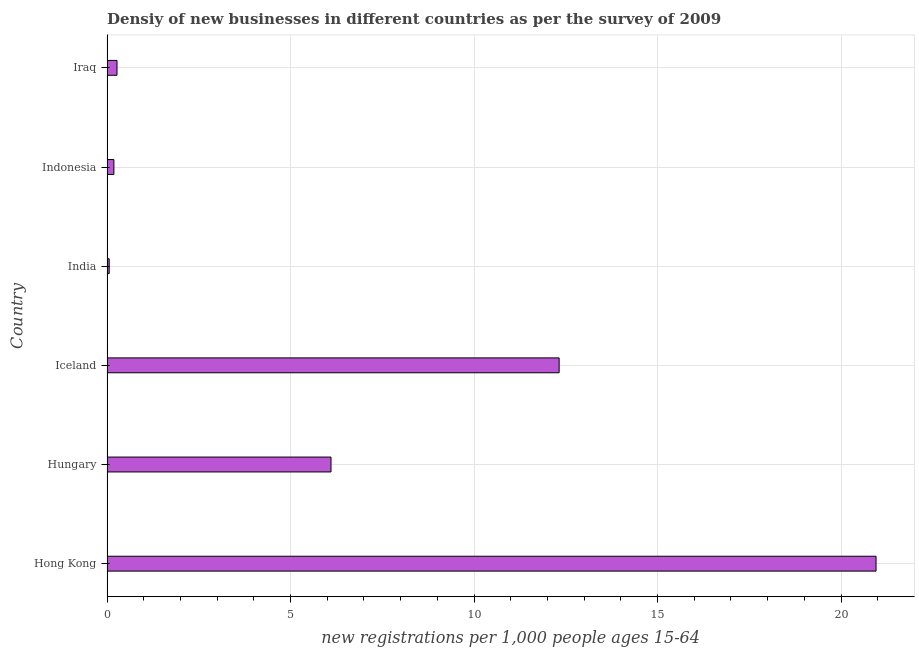Does the graph contain grids?
Your answer should be very brief. Yes. What is the title of the graph?
Keep it short and to the point. Densiy of new businesses in different countries as per the survey of 2009. What is the label or title of the X-axis?
Offer a very short reply. New registrations per 1,0 people ages 15-64. What is the label or title of the Y-axis?
Offer a terse response. Country. What is the density of new business in Hong Kong?
Your answer should be very brief. 20.95. Across all countries, what is the maximum density of new business?
Offer a very short reply. 20.95. Across all countries, what is the minimum density of new business?
Your response must be concise. 0.06. In which country was the density of new business maximum?
Your answer should be compact. Hong Kong. What is the sum of the density of new business?
Make the answer very short. 39.89. What is the difference between the density of new business in Hungary and Iceland?
Your response must be concise. -6.22. What is the average density of new business per country?
Make the answer very short. 6.65. What is the median density of new business?
Keep it short and to the point. 3.19. What is the ratio of the density of new business in Iceland to that in Iraq?
Offer a terse response. 45.17. What is the difference between the highest and the second highest density of new business?
Your response must be concise. 8.63. What is the difference between the highest and the lowest density of new business?
Offer a very short reply. 20.89. How many bars are there?
Ensure brevity in your answer.  6. How many countries are there in the graph?
Offer a terse response. 6. What is the difference between two consecutive major ticks on the X-axis?
Provide a succinct answer. 5. Are the values on the major ticks of X-axis written in scientific E-notation?
Make the answer very short. No. What is the new registrations per 1,000 people ages 15-64 of Hong Kong?
Make the answer very short. 20.95. What is the new registrations per 1,000 people ages 15-64 in Hungary?
Make the answer very short. 6.1. What is the new registrations per 1,000 people ages 15-64 of Iceland?
Give a very brief answer. 12.32. What is the new registrations per 1,000 people ages 15-64 in India?
Make the answer very short. 0.06. What is the new registrations per 1,000 people ages 15-64 of Indonesia?
Keep it short and to the point. 0.19. What is the new registrations per 1,000 people ages 15-64 of Iraq?
Provide a short and direct response. 0.27. What is the difference between the new registrations per 1,000 people ages 15-64 in Hong Kong and Hungary?
Your answer should be compact. 14.85. What is the difference between the new registrations per 1,000 people ages 15-64 in Hong Kong and Iceland?
Offer a terse response. 8.63. What is the difference between the new registrations per 1,000 people ages 15-64 in Hong Kong and India?
Your response must be concise. 20.89. What is the difference between the new registrations per 1,000 people ages 15-64 in Hong Kong and Indonesia?
Your answer should be compact. 20.76. What is the difference between the new registrations per 1,000 people ages 15-64 in Hong Kong and Iraq?
Provide a short and direct response. 20.68. What is the difference between the new registrations per 1,000 people ages 15-64 in Hungary and Iceland?
Ensure brevity in your answer.  -6.22. What is the difference between the new registrations per 1,000 people ages 15-64 in Hungary and India?
Offer a terse response. 6.04. What is the difference between the new registrations per 1,000 people ages 15-64 in Hungary and Indonesia?
Ensure brevity in your answer.  5.92. What is the difference between the new registrations per 1,000 people ages 15-64 in Hungary and Iraq?
Offer a terse response. 5.83. What is the difference between the new registrations per 1,000 people ages 15-64 in Iceland and India?
Ensure brevity in your answer.  12.26. What is the difference between the new registrations per 1,000 people ages 15-64 in Iceland and Indonesia?
Ensure brevity in your answer.  12.13. What is the difference between the new registrations per 1,000 people ages 15-64 in Iceland and Iraq?
Provide a succinct answer. 12.05. What is the difference between the new registrations per 1,000 people ages 15-64 in India and Indonesia?
Keep it short and to the point. -0.13. What is the difference between the new registrations per 1,000 people ages 15-64 in India and Iraq?
Provide a succinct answer. -0.21. What is the difference between the new registrations per 1,000 people ages 15-64 in Indonesia and Iraq?
Ensure brevity in your answer.  -0.09. What is the ratio of the new registrations per 1,000 people ages 15-64 in Hong Kong to that in Hungary?
Ensure brevity in your answer.  3.43. What is the ratio of the new registrations per 1,000 people ages 15-64 in Hong Kong to that in Iceland?
Ensure brevity in your answer.  1.7. What is the ratio of the new registrations per 1,000 people ages 15-64 in Hong Kong to that in India?
Ensure brevity in your answer.  349.29. What is the ratio of the new registrations per 1,000 people ages 15-64 in Hong Kong to that in Indonesia?
Your response must be concise. 111.64. What is the ratio of the new registrations per 1,000 people ages 15-64 in Hong Kong to that in Iraq?
Keep it short and to the point. 76.83. What is the ratio of the new registrations per 1,000 people ages 15-64 in Hungary to that in Iceland?
Make the answer very short. 0.49. What is the ratio of the new registrations per 1,000 people ages 15-64 in Hungary to that in India?
Keep it short and to the point. 101.74. What is the ratio of the new registrations per 1,000 people ages 15-64 in Hungary to that in Indonesia?
Make the answer very short. 32.52. What is the ratio of the new registrations per 1,000 people ages 15-64 in Hungary to that in Iraq?
Your answer should be very brief. 22.38. What is the ratio of the new registrations per 1,000 people ages 15-64 in Iceland to that in India?
Keep it short and to the point. 205.35. What is the ratio of the new registrations per 1,000 people ages 15-64 in Iceland to that in Indonesia?
Offer a terse response. 65.64. What is the ratio of the new registrations per 1,000 people ages 15-64 in Iceland to that in Iraq?
Your response must be concise. 45.17. What is the ratio of the new registrations per 1,000 people ages 15-64 in India to that in Indonesia?
Offer a very short reply. 0.32. What is the ratio of the new registrations per 1,000 people ages 15-64 in India to that in Iraq?
Give a very brief answer. 0.22. What is the ratio of the new registrations per 1,000 people ages 15-64 in Indonesia to that in Iraq?
Offer a terse response. 0.69. 